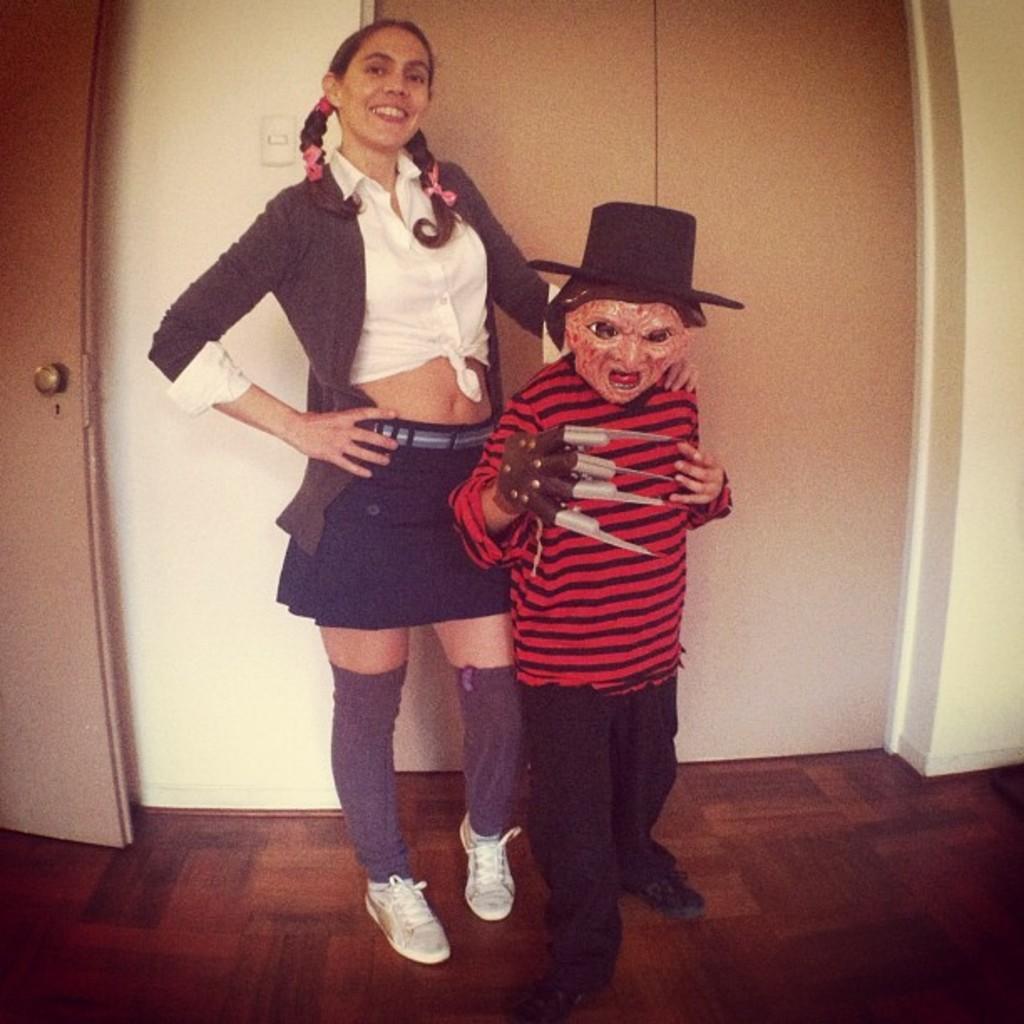Please provide a concise description of this image. In the center of the image there is a woman. There is a boy wearing a mask. In the background of the image there is wall. To the left side of the image there is door. At the bottom of the image there is floor. 